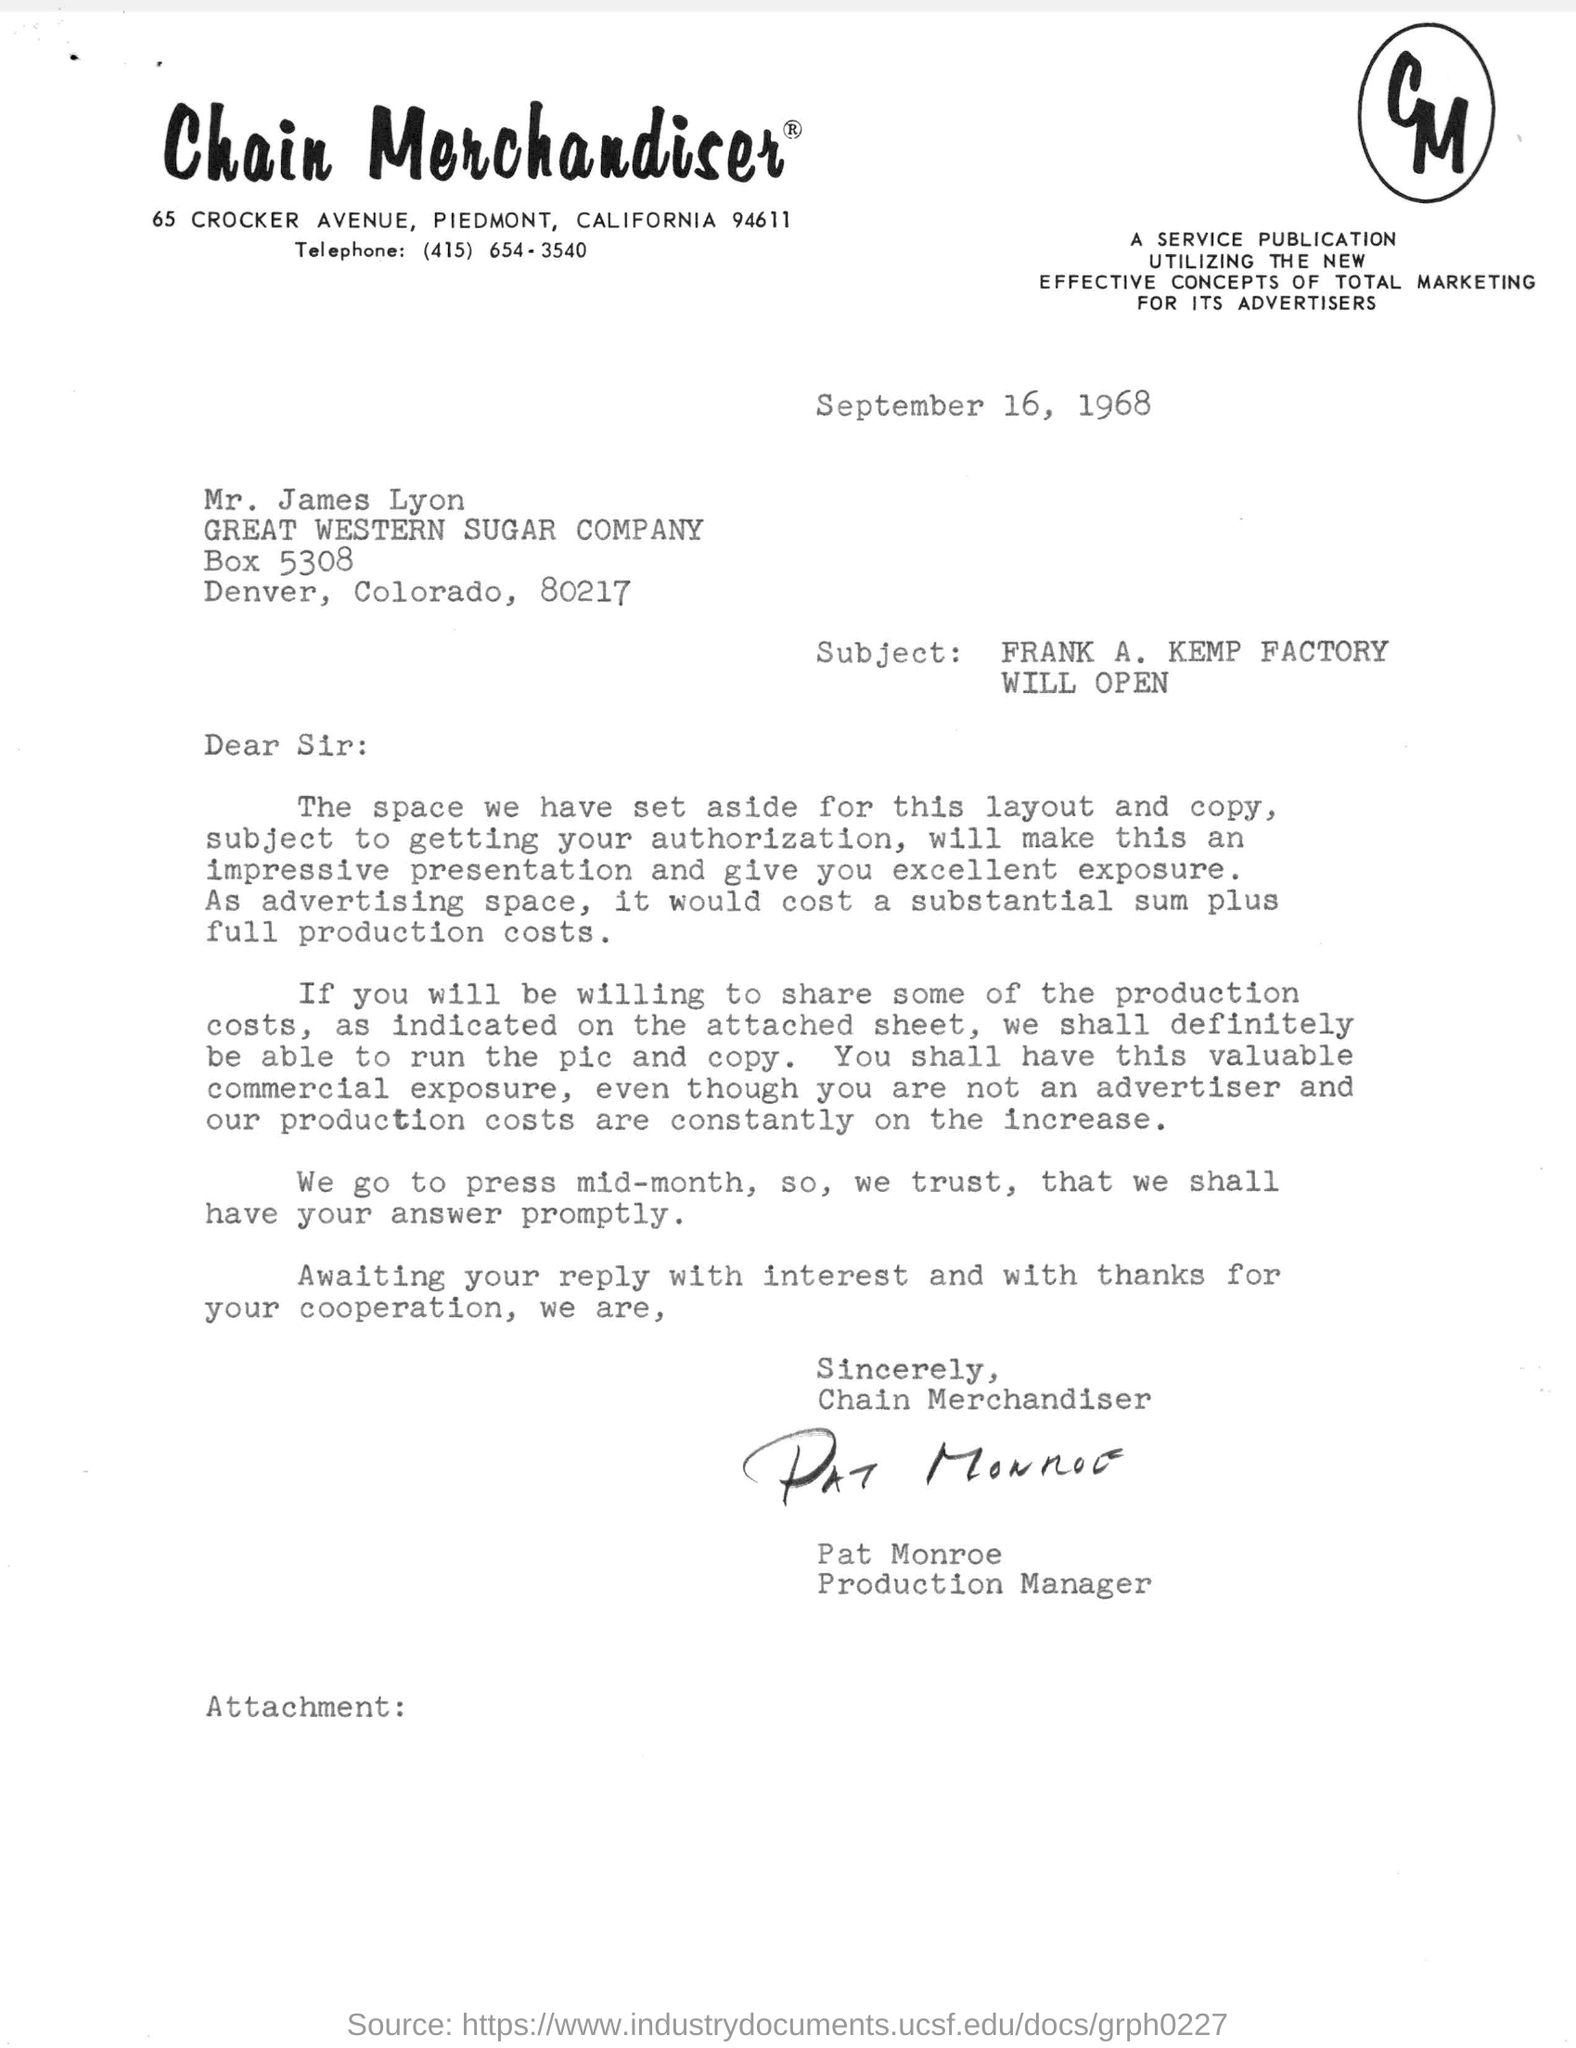What is the date mentioned in the letter?
Your response must be concise. September 16, 1968. What is the Subject of this letter?
Offer a terse response. FRANK A. KEMP FACTORY WILL OPEN. Who has signed the letter?
Make the answer very short. Pat Monroe. To whom the letter is being addressed to ?
Your response must be concise. Mr. James Lyon. What is the telephone no mentioned in the letter?
Your answer should be compact. (415) 654-3540. 